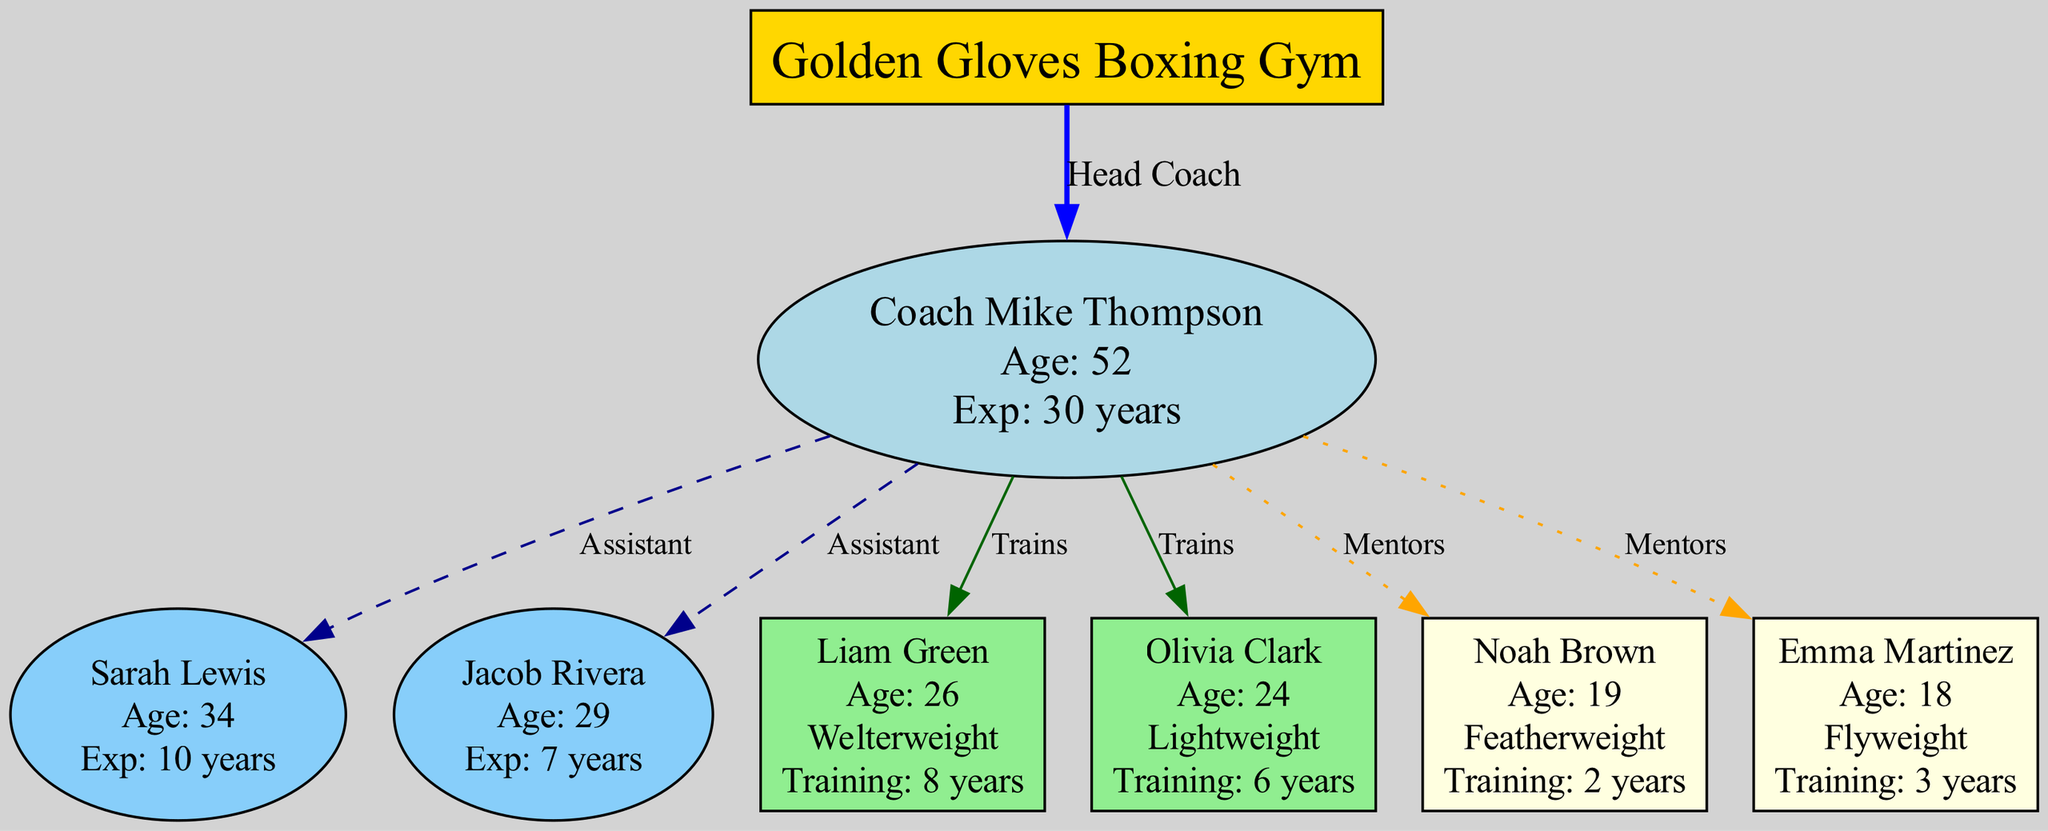What is the name of the head coach? The diagram identifies the head coach as "Coach Mike Thompson." This information is found directly under the node labeled as the head coach.
Answer: Coach Mike Thompson How many assistant coaches are there? The diagram displays two nodes connected as assistant coaches. Counting these nodes gives us the total number of assistant coaches.
Answer: 2 What is Liam Green's weight class? The diagram indicates that Liam Green is in the "Welterweight" category, which is specified within the information associated with his node.
Answer: Welterweight Who mentors Emma Martinez? The diagram shows that Emma Martinez is connected by a "Mentors" edge to the head coach, Coach Mike Thompson, indicating he is responsible for her training.
Answer: Coach Mike Thompson Which boxer has the most years of training? Reviewing the years of training listed in the nodes, Liam Green has 8 years, Olivia Clark has 6 years, Noah Brown has 2 years, and Emma Martinez has 3 years. The highest number is 8, associated with Liam Green.
Answer: Liam Green What age is Noah Brown? The node representing Noah Brown explicitly states his age as "19," providing a clear, direct answer to the question regardless of other context.
Answer: 19 How many total fighters (including senior and up-and-coming) train under the head coach? The diagram has 2 senior boxers and 2 up-and-coming fighters, making a total of 4 fighters. Adding these together gives the total number of fighters under the head coach's guidance.
Answer: 4 Who is the youngest fighter in the gym? Inspecting the ages listed in the nodes, Emma Martinez at age 18 is the youngest compared to Noah Brown (19), Liam Green (26), and Olivia Clark (24).
Answer: Emma Martinez What is the experience of Sarah Lewis? In the assistant coaches section, it states that Sarah Lewis has "10 years" of experience, which is part of the information displayed in her node.
Answer: 10 years 